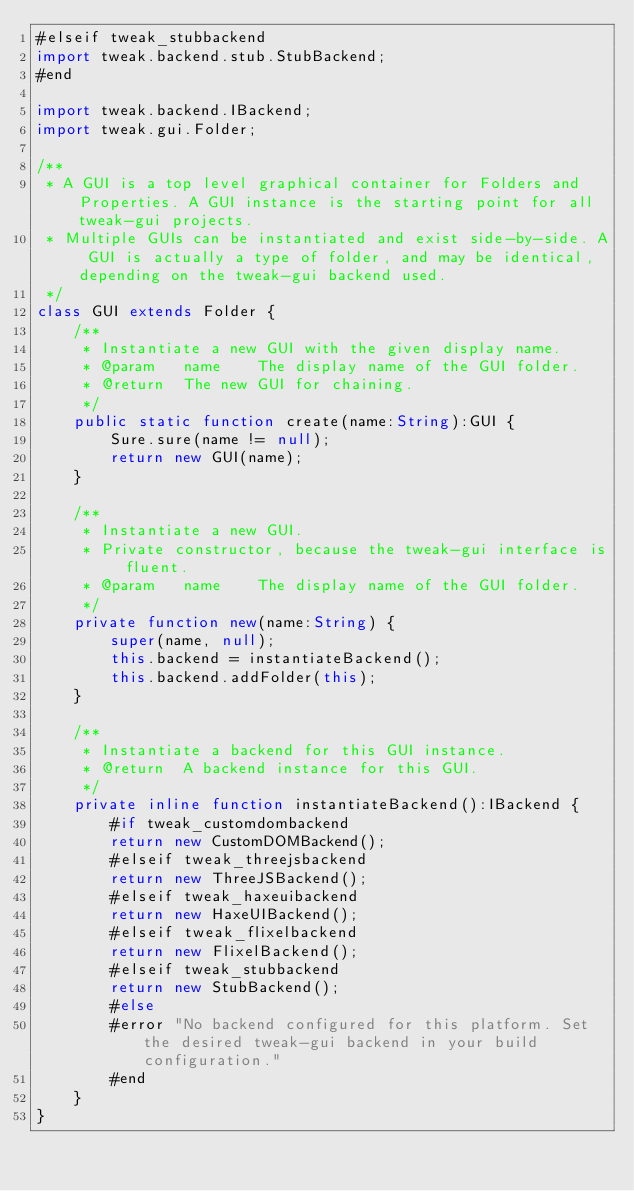<code> <loc_0><loc_0><loc_500><loc_500><_Haxe_>#elseif tweak_stubbackend
import tweak.backend.stub.StubBackend;
#end

import tweak.backend.IBackend;
import tweak.gui.Folder;

/**
 * A GUI is a top level graphical container for Folders and Properties. A GUI instance is the starting point for all tweak-gui projects.
 * Multiple GUIs can be instantiated and exist side-by-side. A GUI is actually a type of folder, and may be identical, depending on the tweak-gui backend used.
 */
class GUI extends Folder {
	/**
	 * Instantiate a new GUI with the given display name.
	 * @param	name	The display name of the GUI folder.
	 * @return	The new GUI for chaining.
	 */ 
	public static function create(name:String):GUI {
		Sure.sure(name != null);
		return new GUI(name);
	}
	
	/**
	 * Instantiate a new GUI.
	 * Private constructor, because the tweak-gui interface is fluent.
	 * @param	name	The display name of the GUI folder.
	 */
	private function new(name:String) {
		super(name, null);
		this.backend = instantiateBackend();
		this.backend.addFolder(this);
	}
	
	/**
	 * Instantiate a backend for this GUI instance.
	 * @return	A backend instance for this GUI.
	 */ 
	private inline function instantiateBackend():IBackend {
		#if tweak_customdombackend
		return new CustomDOMBackend();
		#elseif tweak_threejsbackend
		return new ThreeJSBackend();
		#elseif tweak_haxeuibackend
		return new HaxeUIBackend();
		#elseif tweak_flixelbackend
		return new FlixelBackend();
		#elseif tweak_stubbackend
		return new StubBackend();
		#else
		#error "No backend configured for this platform. Set the desired tweak-gui backend in your build configuration."
		#end
	}
}</code> 